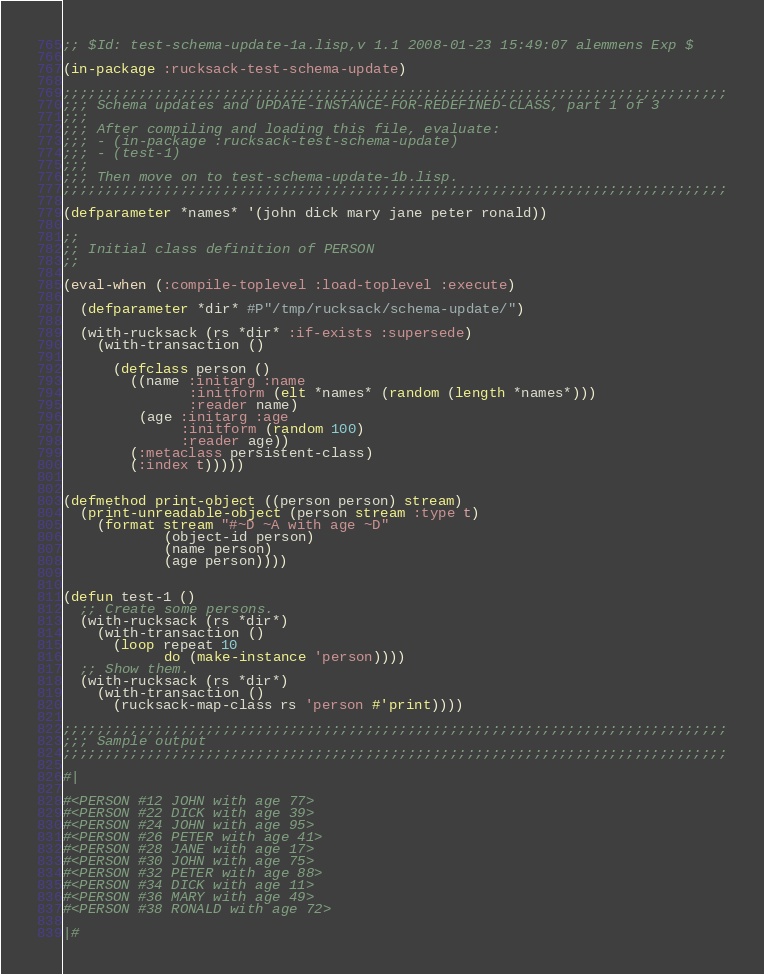Convert code to text. <code><loc_0><loc_0><loc_500><loc_500><_Lisp_>;; $Id: test-schema-update-1a.lisp,v 1.1 2008-01-23 15:49:07 alemmens Exp $

(in-package :rucksack-test-schema-update)

;;;;;;;;;;;;;;;;;;;;;;;;;;;;;;;;;;;;;;;;;;;;;;;;;;;;;;;;;;;;;;;;;;;;;;;;;;;;;;;
;;; Schema updates and UPDATE-INSTANCE-FOR-REDEFINED-CLASS, part 1 of 3
;;;
;;; After compiling and loading this file, evaluate:
;;; - (in-package :rucksack-test-schema-update)
;;; - (test-1)
;;;
;;; Then move on to test-schema-update-1b.lisp.
;;;;;;;;;;;;;;;;;;;;;;;;;;;;;;;;;;;;;;;;;;;;;;;;;;;;;;;;;;;;;;;;;;;;;;;;;;;;;;;

(defparameter *names* '(john dick mary jane peter ronald))

;;
;; Initial class definition of PERSON
;;

(eval-when (:compile-toplevel :load-toplevel :execute)

  (defparameter *dir* #P"/tmp/rucksack/schema-update/")
  
  (with-rucksack (rs *dir* :if-exists :supersede)
    (with-transaction ()
      
      (defclass person ()
        ((name :initarg :name
               :initform (elt *names* (random (length *names*)))
               :reader name)
         (age :initarg :age
              :initform (random 100)
              :reader age))
        (:metaclass persistent-class)
        (:index t)))))


(defmethod print-object ((person person) stream)
  (print-unreadable-object (person stream :type t)
    (format stream "#~D ~A with age ~D"
            (object-id person)
            (name person)
            (age person))))


(defun test-1 ()
  ;; Create some persons.
  (with-rucksack (rs *dir*)
    (with-transaction ()
      (loop repeat 10
            do (make-instance 'person))))
  ;; Show them.
  (with-rucksack (rs *dir*)
    (with-transaction ()
      (rucksack-map-class rs 'person #'print))))

;;;;;;;;;;;;;;;;;;;;;;;;;;;;;;;;;;;;;;;;;;;;;;;;;;;;;;;;;;;;;;;;;;;;;;;;;;;;;;;
;;; Sample output
;;;;;;;;;;;;;;;;;;;;;;;;;;;;;;;;;;;;;;;;;;;;;;;;;;;;;;;;;;;;;;;;;;;;;;;;;;;;;;;

#|

#<PERSON #12 JOHN with age 77> 
#<PERSON #22 DICK with age 39> 
#<PERSON #24 JOHN with age 95> 
#<PERSON #26 PETER with age 41> 
#<PERSON #28 JANE with age 17> 
#<PERSON #30 JOHN with age 75> 
#<PERSON #32 PETER with age 88> 
#<PERSON #34 DICK with age 11> 
#<PERSON #36 MARY with age 49> 
#<PERSON #38 RONALD with age 72> 

|#
</code> 